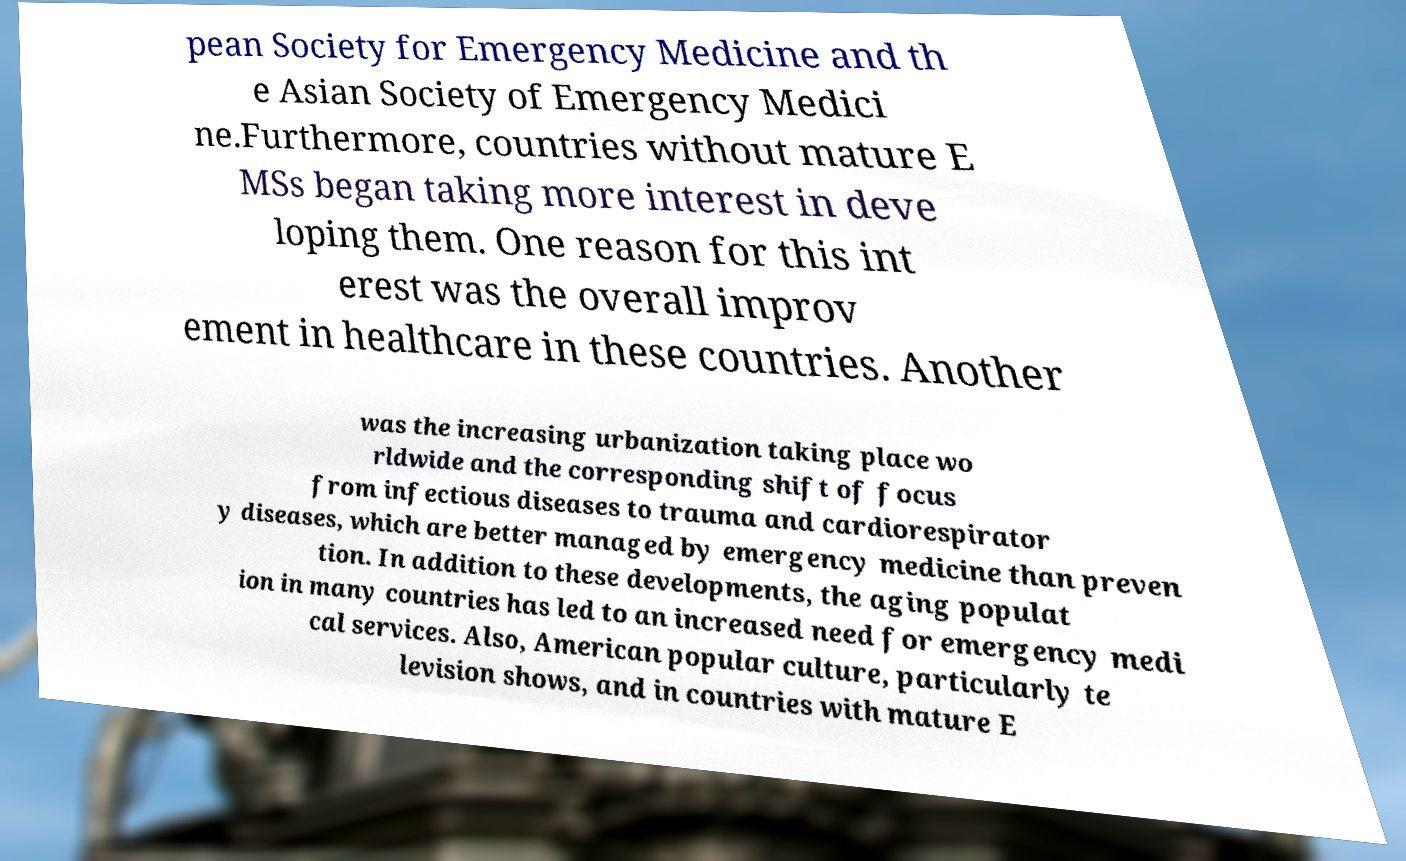I need the written content from this picture converted into text. Can you do that? pean Society for Emergency Medicine and th e Asian Society of Emergency Medici ne.Furthermore, countries without mature E MSs began taking more interest in deve loping them. One reason for this int erest was the overall improv ement in healthcare in these countries. Another was the increasing urbanization taking place wo rldwide and the corresponding shift of focus from infectious diseases to trauma and cardiorespirator y diseases, which are better managed by emergency medicine than preven tion. In addition to these developments, the aging populat ion in many countries has led to an increased need for emergency medi cal services. Also, American popular culture, particularly te levision shows, and in countries with mature E 